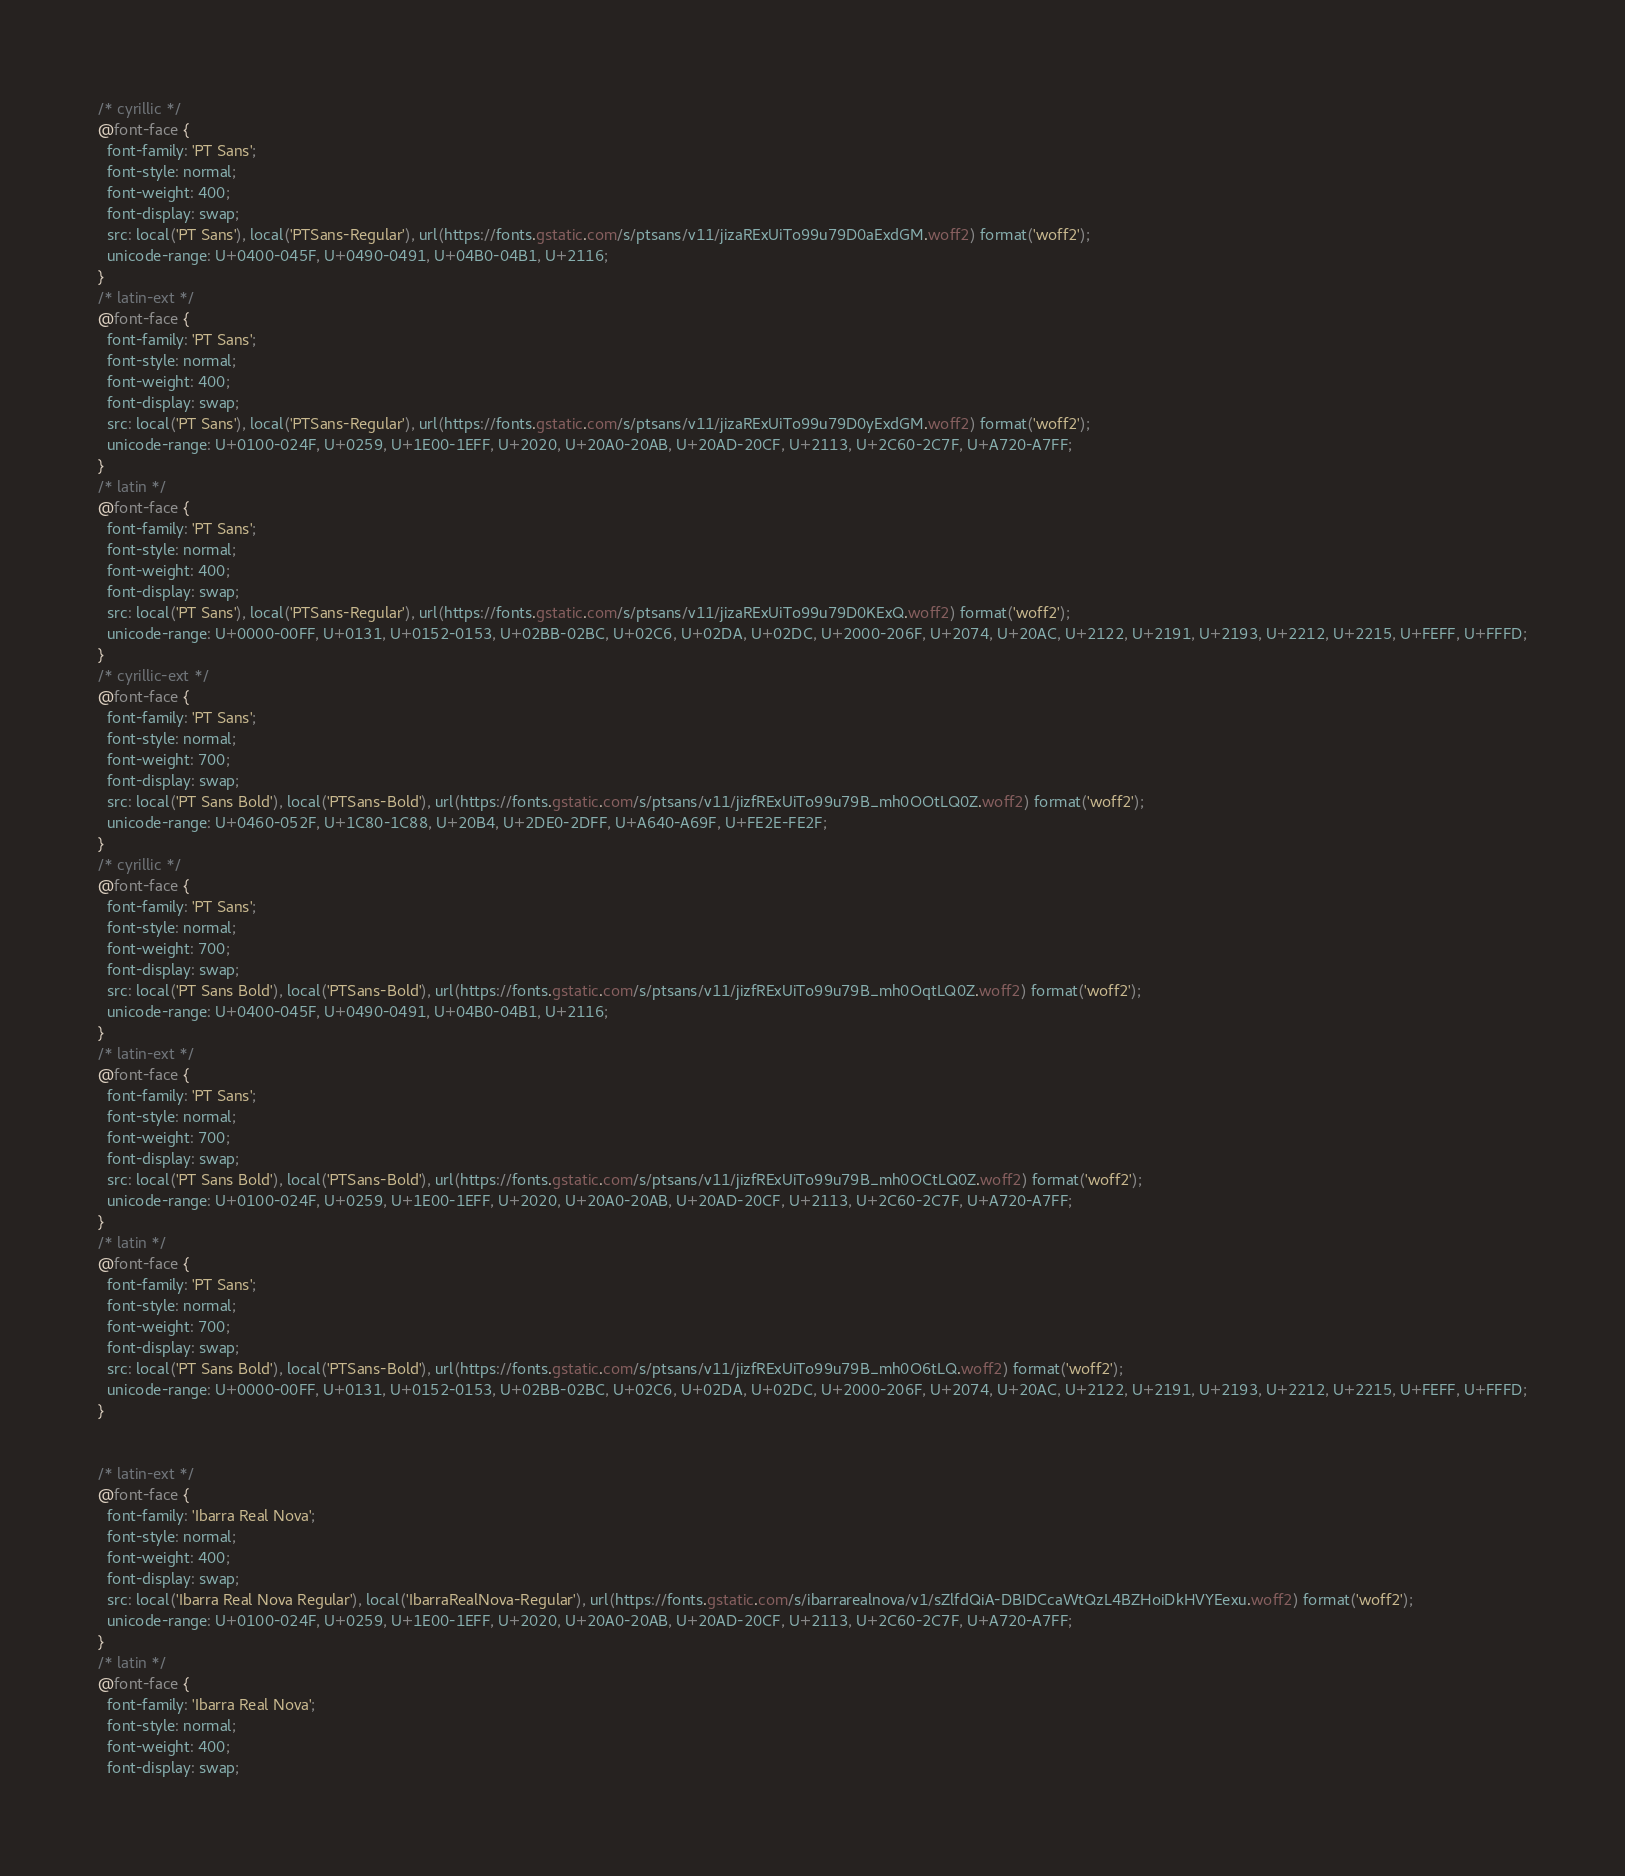Convert code to text. <code><loc_0><loc_0><loc_500><loc_500><_CSS_>/* cyrillic */
@font-face {
  font-family: 'PT Sans';
  font-style: normal;
  font-weight: 400;
  font-display: swap;
  src: local('PT Sans'), local('PTSans-Regular'), url(https://fonts.gstatic.com/s/ptsans/v11/jizaRExUiTo99u79D0aExdGM.woff2) format('woff2');
  unicode-range: U+0400-045F, U+0490-0491, U+04B0-04B1, U+2116;
}
/* latin-ext */
@font-face {
  font-family: 'PT Sans';
  font-style: normal;
  font-weight: 400;
  font-display: swap;
  src: local('PT Sans'), local('PTSans-Regular'), url(https://fonts.gstatic.com/s/ptsans/v11/jizaRExUiTo99u79D0yExdGM.woff2) format('woff2');
  unicode-range: U+0100-024F, U+0259, U+1E00-1EFF, U+2020, U+20A0-20AB, U+20AD-20CF, U+2113, U+2C60-2C7F, U+A720-A7FF;
}
/* latin */
@font-face {
  font-family: 'PT Sans';
  font-style: normal;
  font-weight: 400;
  font-display: swap;
  src: local('PT Sans'), local('PTSans-Regular'), url(https://fonts.gstatic.com/s/ptsans/v11/jizaRExUiTo99u79D0KExQ.woff2) format('woff2');
  unicode-range: U+0000-00FF, U+0131, U+0152-0153, U+02BB-02BC, U+02C6, U+02DA, U+02DC, U+2000-206F, U+2074, U+20AC, U+2122, U+2191, U+2193, U+2212, U+2215, U+FEFF, U+FFFD;
}
/* cyrillic-ext */
@font-face {
  font-family: 'PT Sans';
  font-style: normal;
  font-weight: 700;
  font-display: swap;
  src: local('PT Sans Bold'), local('PTSans-Bold'), url(https://fonts.gstatic.com/s/ptsans/v11/jizfRExUiTo99u79B_mh0OOtLQ0Z.woff2) format('woff2');
  unicode-range: U+0460-052F, U+1C80-1C88, U+20B4, U+2DE0-2DFF, U+A640-A69F, U+FE2E-FE2F;
}
/* cyrillic */
@font-face {
  font-family: 'PT Sans';
  font-style: normal;
  font-weight: 700;
  font-display: swap;
  src: local('PT Sans Bold'), local('PTSans-Bold'), url(https://fonts.gstatic.com/s/ptsans/v11/jizfRExUiTo99u79B_mh0OqtLQ0Z.woff2) format('woff2');
  unicode-range: U+0400-045F, U+0490-0491, U+04B0-04B1, U+2116;
}
/* latin-ext */
@font-face {
  font-family: 'PT Sans';
  font-style: normal;
  font-weight: 700;
  font-display: swap;
  src: local('PT Sans Bold'), local('PTSans-Bold'), url(https://fonts.gstatic.com/s/ptsans/v11/jizfRExUiTo99u79B_mh0OCtLQ0Z.woff2) format('woff2');
  unicode-range: U+0100-024F, U+0259, U+1E00-1EFF, U+2020, U+20A0-20AB, U+20AD-20CF, U+2113, U+2C60-2C7F, U+A720-A7FF;
}
/* latin */
@font-face {
  font-family: 'PT Sans';
  font-style: normal;
  font-weight: 700;
  font-display: swap;
  src: local('PT Sans Bold'), local('PTSans-Bold'), url(https://fonts.gstatic.com/s/ptsans/v11/jizfRExUiTo99u79B_mh0O6tLQ.woff2) format('woff2');
  unicode-range: U+0000-00FF, U+0131, U+0152-0153, U+02BB-02BC, U+02C6, U+02DA, U+02DC, U+2000-206F, U+2074, U+20AC, U+2122, U+2191, U+2193, U+2212, U+2215, U+FEFF, U+FFFD;
}


/* latin-ext */
@font-face {
  font-family: 'Ibarra Real Nova';
  font-style: normal;
  font-weight: 400;
  font-display: swap;
  src: local('Ibarra Real Nova Regular'), local('IbarraRealNova-Regular'), url(https://fonts.gstatic.com/s/ibarrarealnova/v1/sZlfdQiA-DBIDCcaWtQzL4BZHoiDkHVYEexu.woff2) format('woff2');
  unicode-range: U+0100-024F, U+0259, U+1E00-1EFF, U+2020, U+20A0-20AB, U+20AD-20CF, U+2113, U+2C60-2C7F, U+A720-A7FF;
}
/* latin */
@font-face {
  font-family: 'Ibarra Real Nova';
  font-style: normal;
  font-weight: 400;
  font-display: swap;</code> 